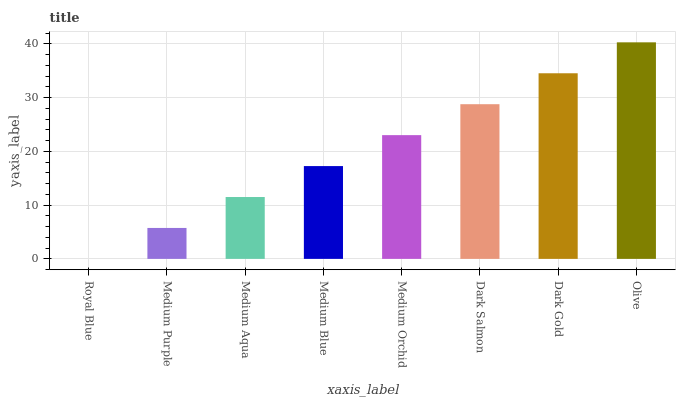Is Royal Blue the minimum?
Answer yes or no. Yes. Is Olive the maximum?
Answer yes or no. Yes. Is Medium Purple the minimum?
Answer yes or no. No. Is Medium Purple the maximum?
Answer yes or no. No. Is Medium Purple greater than Royal Blue?
Answer yes or no. Yes. Is Royal Blue less than Medium Purple?
Answer yes or no. Yes. Is Royal Blue greater than Medium Purple?
Answer yes or no. No. Is Medium Purple less than Royal Blue?
Answer yes or no. No. Is Medium Orchid the high median?
Answer yes or no. Yes. Is Medium Blue the low median?
Answer yes or no. Yes. Is Medium Aqua the high median?
Answer yes or no. No. Is Medium Purple the low median?
Answer yes or no. No. 